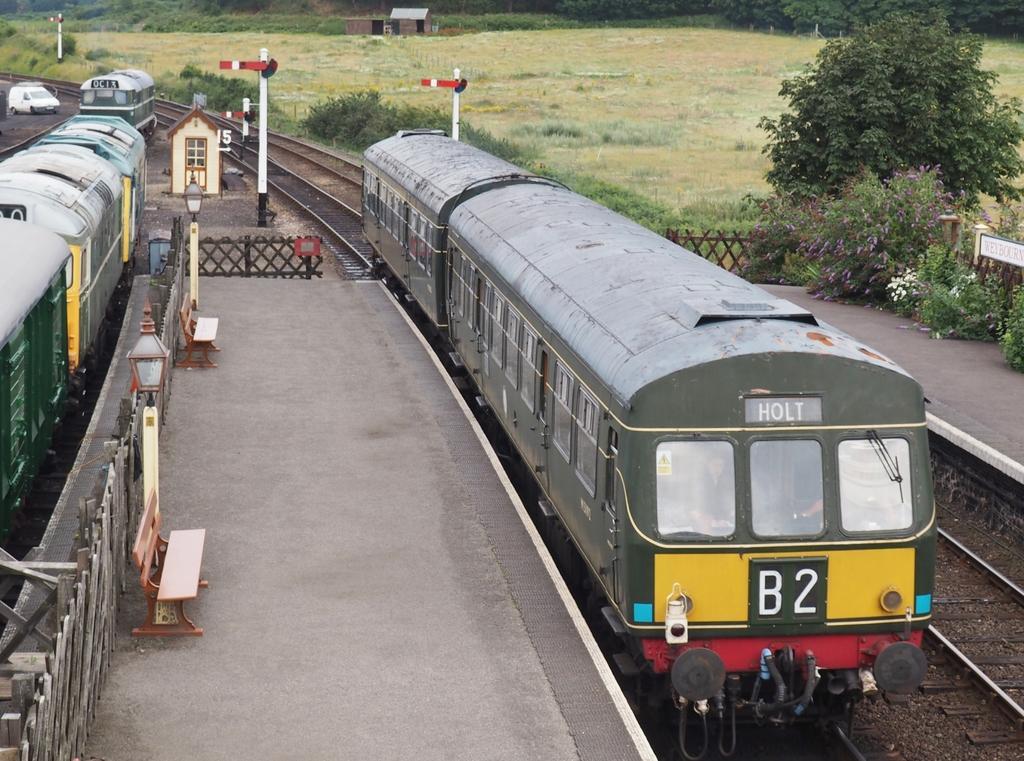Describe this image in one or two sentences. In this image, we can see some trains and tracks. We can also see some poles. Among them, we can see some poles with lights. We can see the fence and some benches. We can also see some houses. We can see the ground covered with grass, plants and trees. We can also see some boards. 